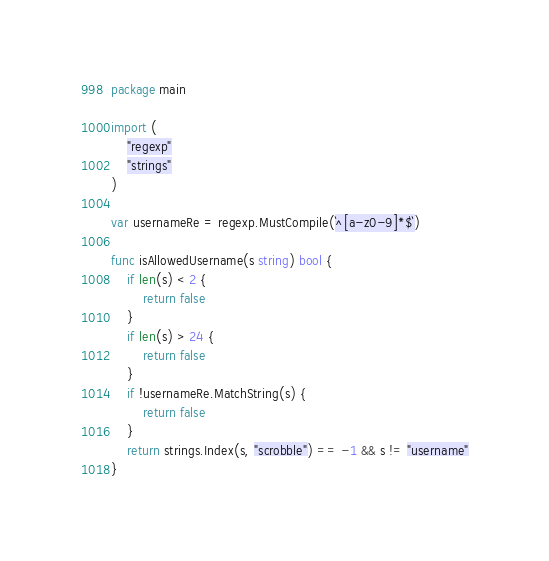<code> <loc_0><loc_0><loc_500><loc_500><_Go_>package main

import (
	"regexp"
	"strings"
)

var usernameRe = regexp.MustCompile(`^[a-z0-9]*$`)

func isAllowedUsername(s string) bool {
	if len(s) < 2 {
		return false
	}
	if len(s) > 24 {
		return false
	}
	if !usernameRe.MatchString(s) {
		return false
	}
	return strings.Index(s, "scrobble") == -1 && s != "username"
}
</code> 